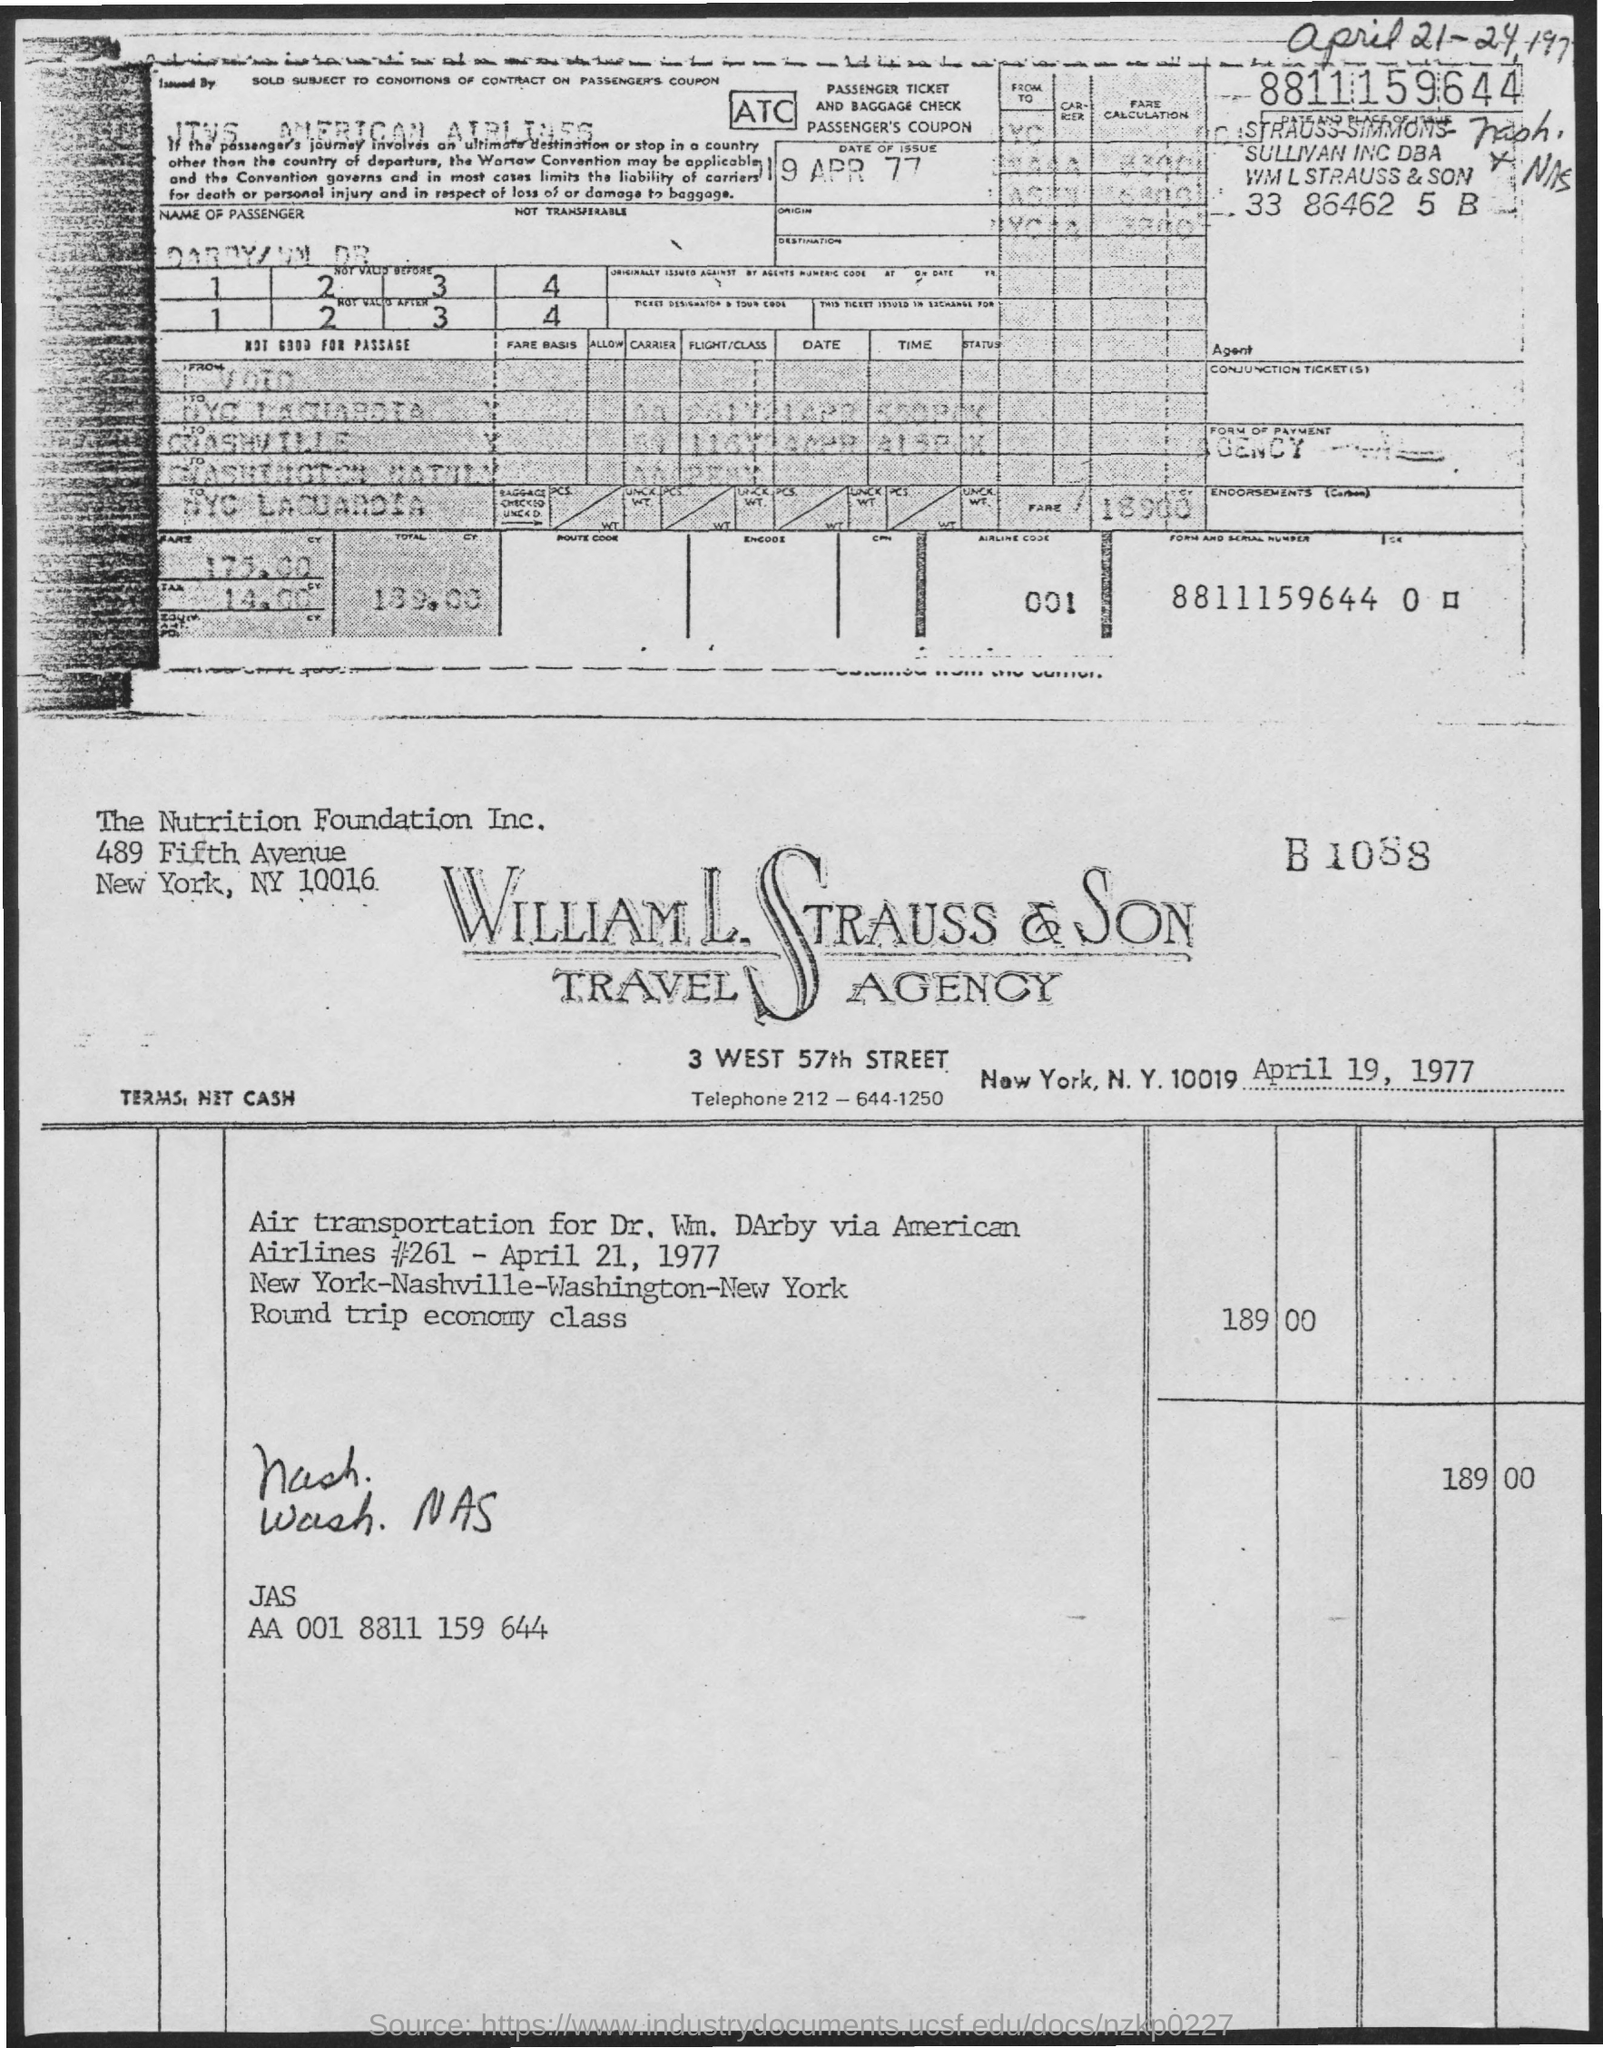Mention a couple of crucial points in this snapshot. The cost on the invoice is 189 dollars and 00 cents. The invoice is dated April 19, 1977. Airline economy class is mentioned as the type of class. 